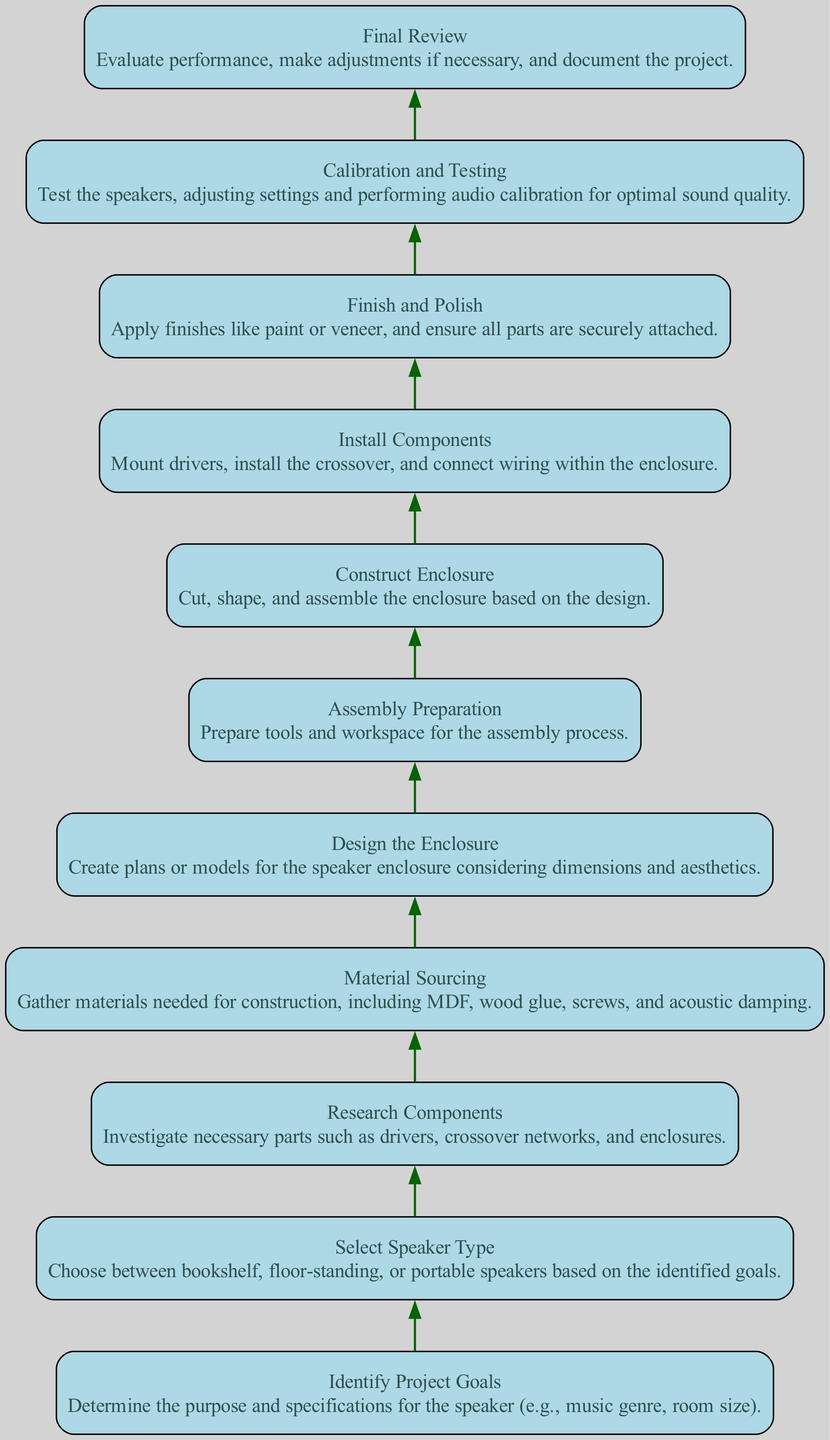What is the first step in the DIY speaker project? The first step is "Identify Project Goals," which entails determining the purpose and specifications for the speaker.
Answer: Identify Project Goals How many total steps are there in the workflow? By counting the nodes in the diagram, there are 11 steps from "Identify Project Goals" to "Final Review."
Answer: 11 What step comes right after "Material Sourcing"? The step that follows "Material Sourcing" is "Design the Enclosure," indicating the next phase in the workflow after gathering materials.
Answer: Design the Enclosure Which step involves testing the speakers? The "Calibration and Testing" step is dedicated to testing the speakers and making adjustments for optimal sound quality.
Answer: Calibration and Testing What is the last step in the project workflow? The final step is "Final Review," where performance is evaluated, and the project is documented.
Answer: Final Review What action follows "Install Components"? The action that follows "Install Components" is "Finish and Polish," which involves applying finishes and ensuring secure assembly.
Answer: Finish and Polish Which two steps are related by an edge in the diagram? "Research Components" and "Material Sourcing" are related; "Material Sourcing" follows "Research Components" as you gather parts after researching them.
Answer: Research Components, Material Sourcing What is the purpose of the "Assembly Preparation" step? "Assembly Preparation" is focused on preparing tools and workspace necessary for the assembly process, setting the stage for construction.
Answer: Preparing tools and workspace How would you summarize the purpose of the "Construct Enclosure" step? The "Construct Enclosure" step is about cutting, shaping, and assembling the enclosure based on the design created earlier.
Answer: Cutting, shaping, and assembling enclosure 